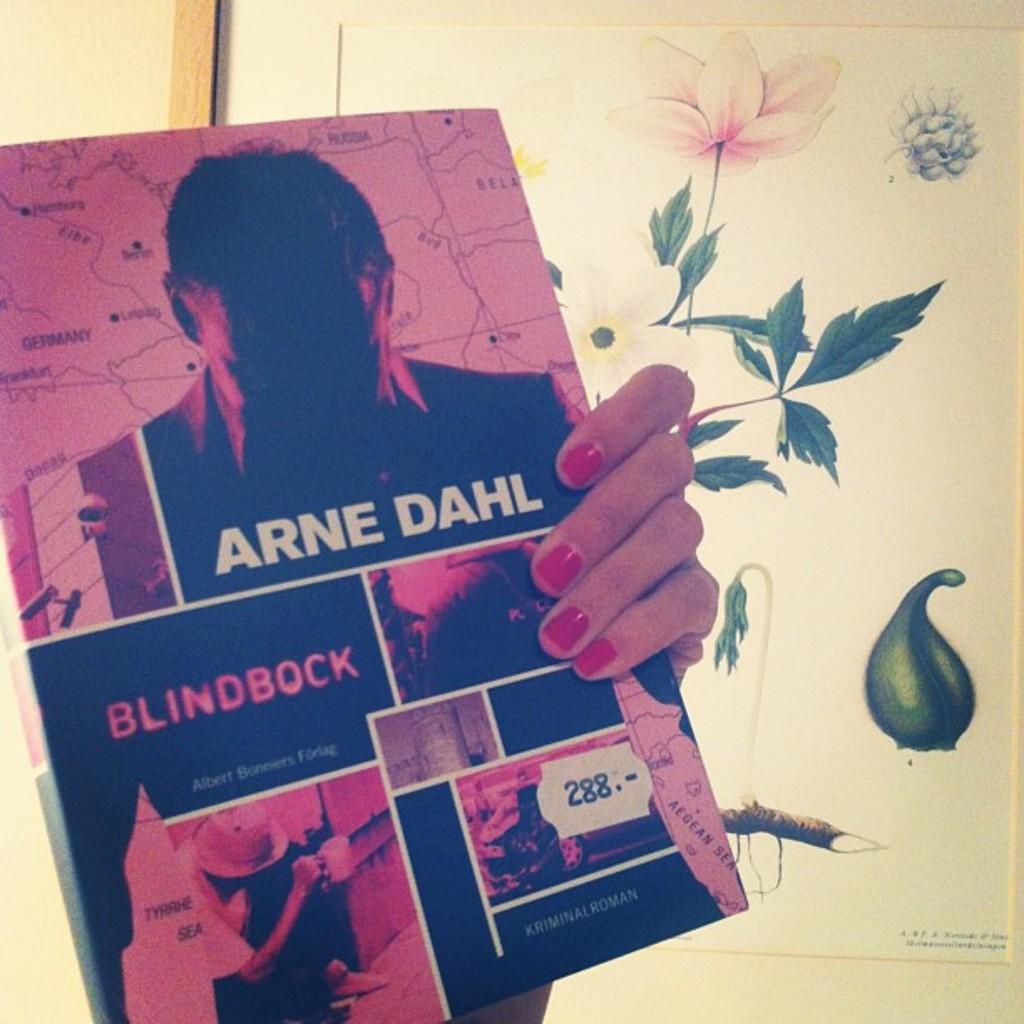Can you describe this image briefly? In this picture there is a person holding the book. On the book there is a picture of two persons and there is a text. At the back there is a frame on the wall, there is a painting of a plant on the frame. 